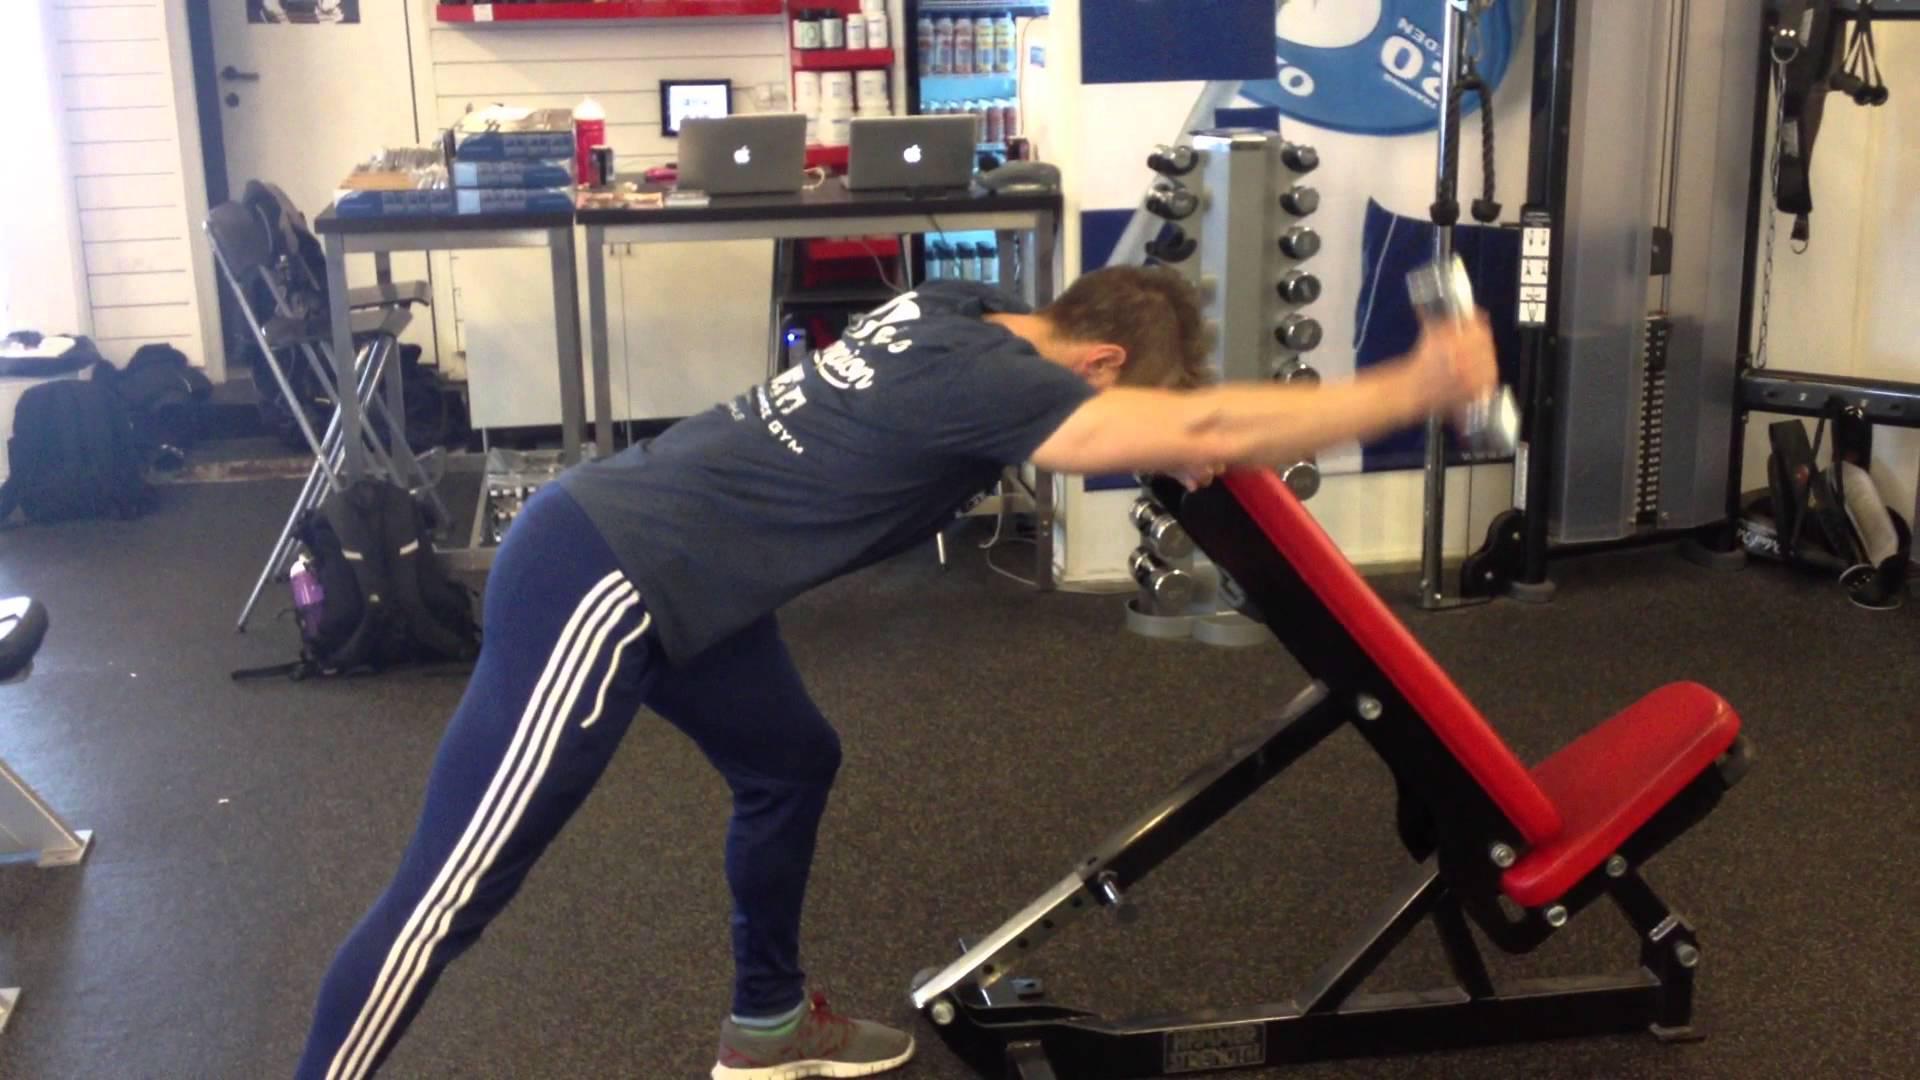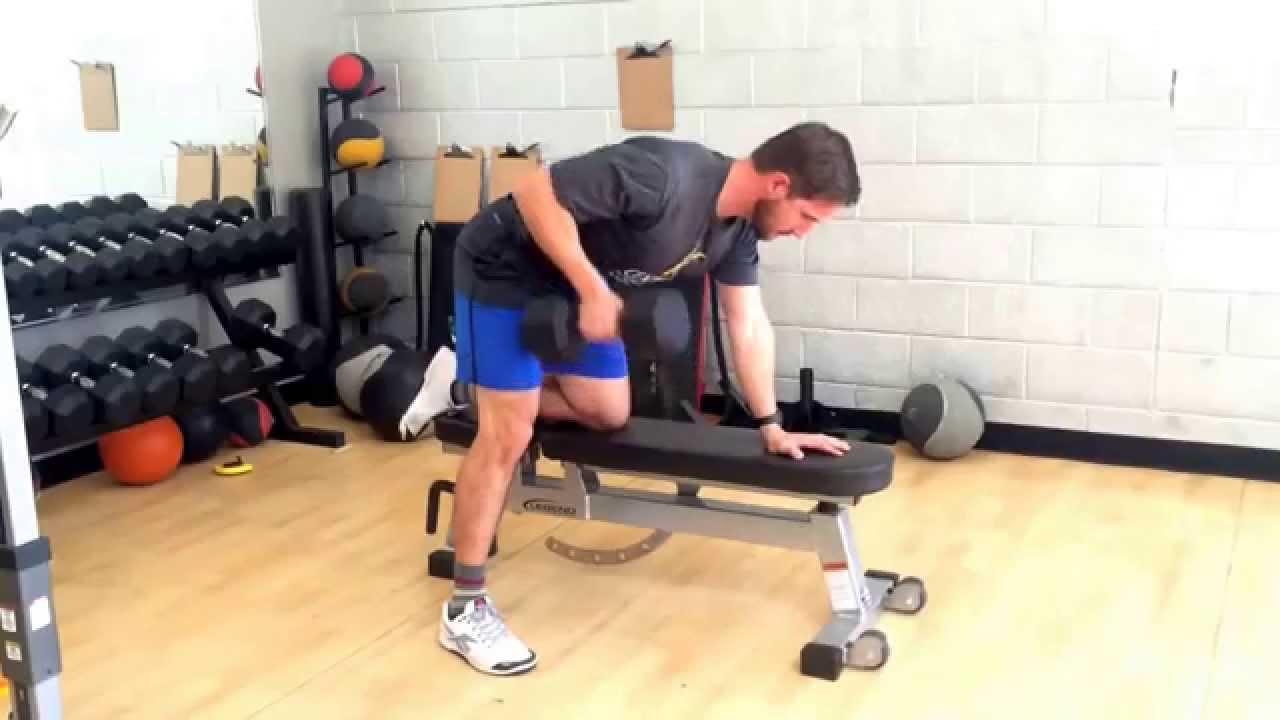The first image is the image on the left, the second image is the image on the right. For the images shown, is this caption "An image shows three pale-haired women sitting on pink exercise balls." true? Answer yes or no. No. The first image is the image on the left, the second image is the image on the right. Analyze the images presented: Is the assertion "Three women are sitting on exercise balls in one of the images." valid? Answer yes or no. No. 